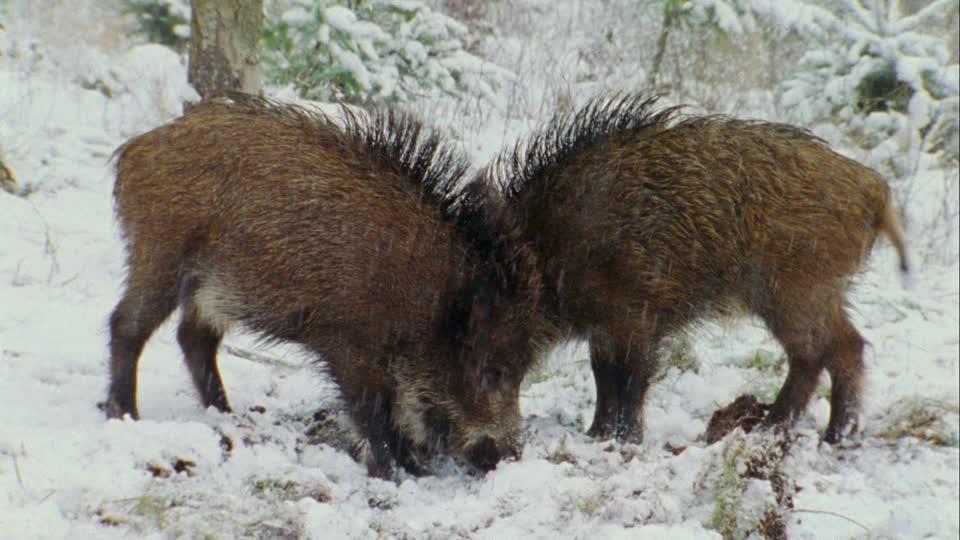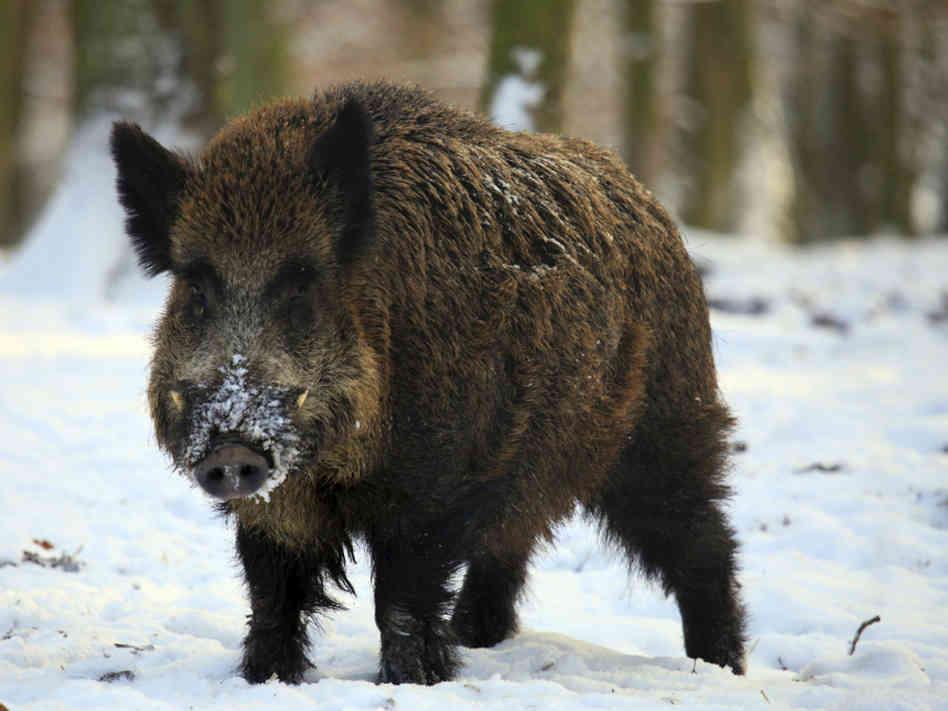The first image is the image on the left, the second image is the image on the right. For the images shown, is this caption "There are at least two animals in one of the images." true? Answer yes or no. Yes. 